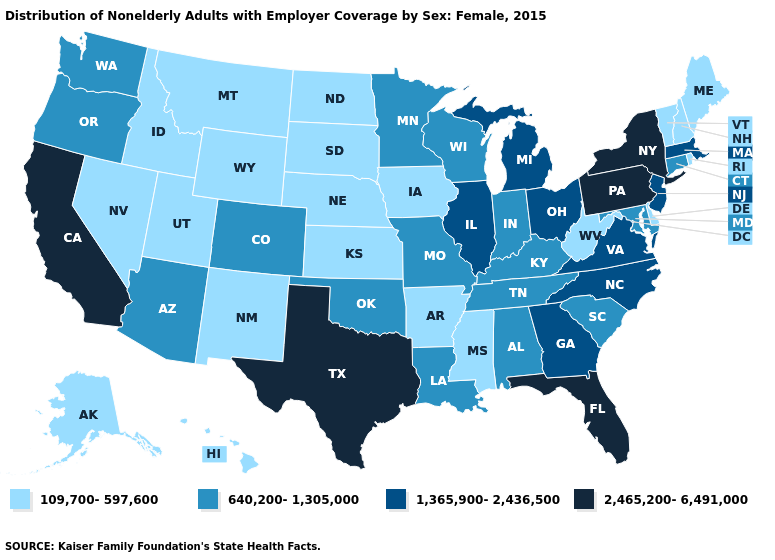Name the states that have a value in the range 640,200-1,305,000?
Be succinct. Alabama, Arizona, Colorado, Connecticut, Indiana, Kentucky, Louisiana, Maryland, Minnesota, Missouri, Oklahoma, Oregon, South Carolina, Tennessee, Washington, Wisconsin. Name the states that have a value in the range 109,700-597,600?
Give a very brief answer. Alaska, Arkansas, Delaware, Hawaii, Idaho, Iowa, Kansas, Maine, Mississippi, Montana, Nebraska, Nevada, New Hampshire, New Mexico, North Dakota, Rhode Island, South Dakota, Utah, Vermont, West Virginia, Wyoming. Name the states that have a value in the range 640,200-1,305,000?
Quick response, please. Alabama, Arizona, Colorado, Connecticut, Indiana, Kentucky, Louisiana, Maryland, Minnesota, Missouri, Oklahoma, Oregon, South Carolina, Tennessee, Washington, Wisconsin. Name the states that have a value in the range 109,700-597,600?
Quick response, please. Alaska, Arkansas, Delaware, Hawaii, Idaho, Iowa, Kansas, Maine, Mississippi, Montana, Nebraska, Nevada, New Hampshire, New Mexico, North Dakota, Rhode Island, South Dakota, Utah, Vermont, West Virginia, Wyoming. Does New York have the lowest value in the USA?
Write a very short answer. No. How many symbols are there in the legend?
Short answer required. 4. What is the highest value in the USA?
Keep it brief. 2,465,200-6,491,000. Name the states that have a value in the range 2,465,200-6,491,000?
Concise answer only. California, Florida, New York, Pennsylvania, Texas. Does New York have the highest value in the USA?
Keep it brief. Yes. What is the value of Colorado?
Write a very short answer. 640,200-1,305,000. Which states have the lowest value in the South?
Be succinct. Arkansas, Delaware, Mississippi, West Virginia. Does the first symbol in the legend represent the smallest category?
Short answer required. Yes. What is the highest value in the Northeast ?
Answer briefly. 2,465,200-6,491,000. Does the map have missing data?
Short answer required. No. Name the states that have a value in the range 640,200-1,305,000?
Quick response, please. Alabama, Arizona, Colorado, Connecticut, Indiana, Kentucky, Louisiana, Maryland, Minnesota, Missouri, Oklahoma, Oregon, South Carolina, Tennessee, Washington, Wisconsin. 